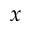<formula> <loc_0><loc_0><loc_500><loc_500>x</formula> 